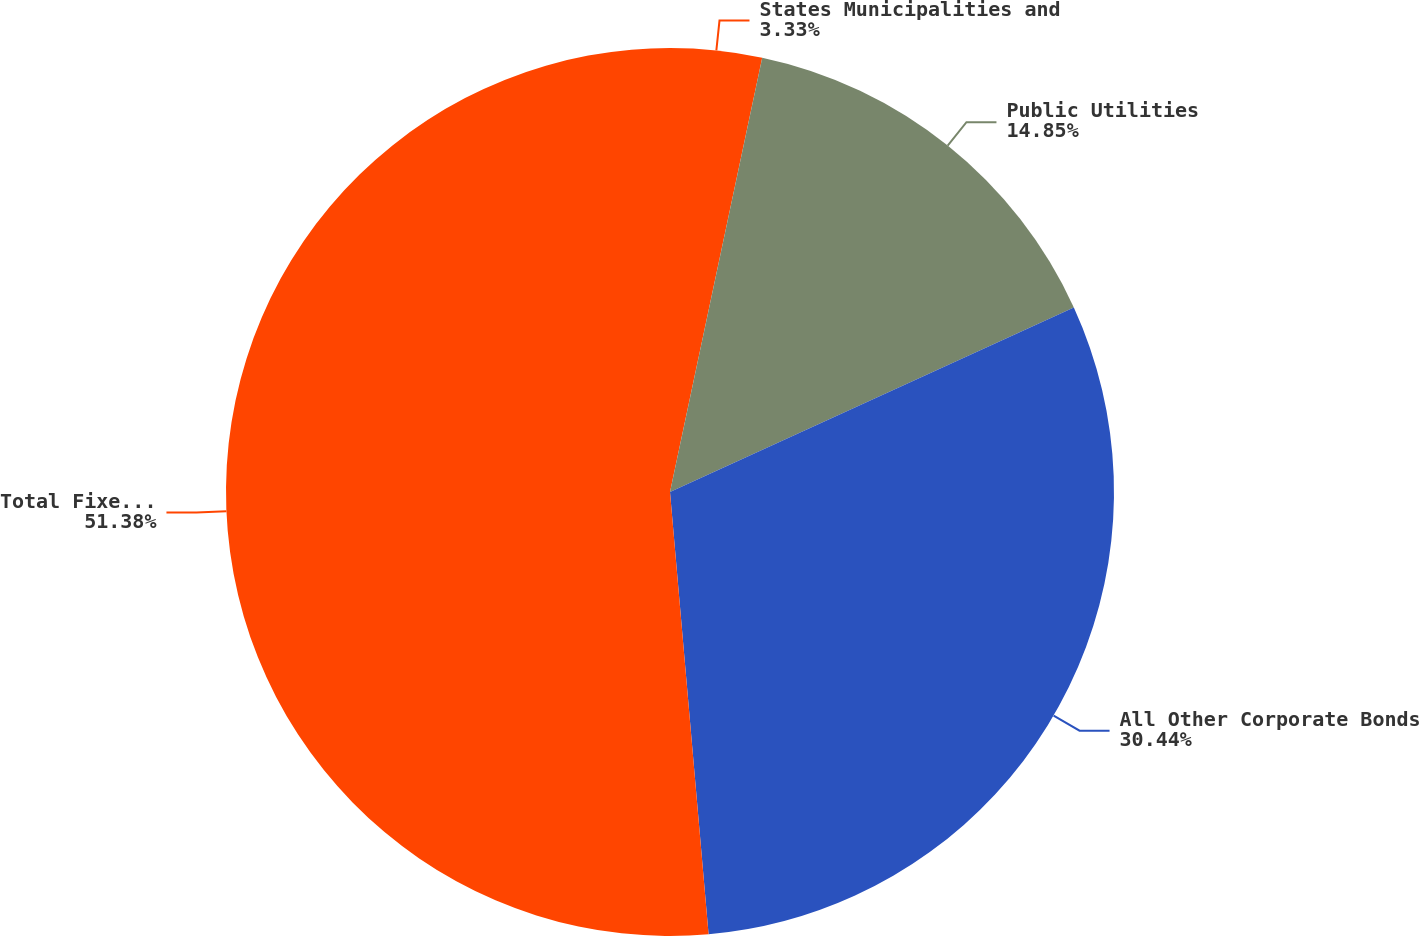<chart> <loc_0><loc_0><loc_500><loc_500><pie_chart><fcel>States Municipalities and<fcel>Public Utilities<fcel>All Other Corporate Bonds<fcel>Total Fixed Maturity<nl><fcel>3.33%<fcel>14.85%<fcel>30.44%<fcel>51.39%<nl></chart> 